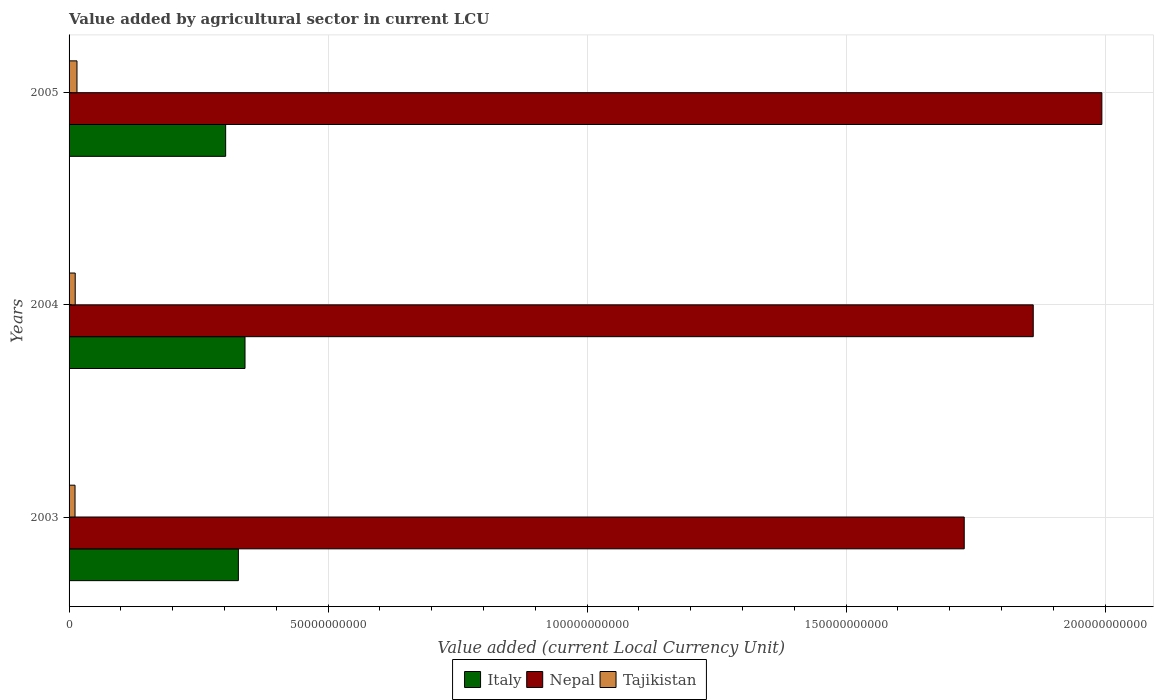How many different coloured bars are there?
Ensure brevity in your answer.  3. How many groups of bars are there?
Offer a very short reply. 3. What is the value added by agricultural sector in Nepal in 2005?
Ensure brevity in your answer.  1.99e+11. Across all years, what is the maximum value added by agricultural sector in Tajikistan?
Give a very brief answer. 1.53e+09. Across all years, what is the minimum value added by agricultural sector in Tajikistan?
Keep it short and to the point. 1.15e+09. In which year was the value added by agricultural sector in Nepal maximum?
Your answer should be compact. 2005. In which year was the value added by agricultural sector in Italy minimum?
Provide a short and direct response. 2005. What is the total value added by agricultural sector in Italy in the graph?
Keep it short and to the point. 9.69e+1. What is the difference between the value added by agricultural sector in Nepal in 2003 and that in 2005?
Provide a short and direct response. -2.66e+1. What is the difference between the value added by agricultural sector in Italy in 2004 and the value added by agricultural sector in Tajikistan in 2003?
Provide a succinct answer. 3.28e+1. What is the average value added by agricultural sector in Tajikistan per year?
Make the answer very short. 1.29e+09. In the year 2004, what is the difference between the value added by agricultural sector in Tajikistan and value added by agricultural sector in Nepal?
Ensure brevity in your answer.  -1.85e+11. What is the ratio of the value added by agricultural sector in Italy in 2003 to that in 2005?
Provide a short and direct response. 1.08. Is the value added by agricultural sector in Nepal in 2004 less than that in 2005?
Ensure brevity in your answer.  Yes. Is the difference between the value added by agricultural sector in Tajikistan in 2003 and 2005 greater than the difference between the value added by agricultural sector in Nepal in 2003 and 2005?
Offer a very short reply. Yes. What is the difference between the highest and the second highest value added by agricultural sector in Nepal?
Your answer should be very brief. 1.32e+1. What is the difference between the highest and the lowest value added by agricultural sector in Nepal?
Offer a terse response. 2.66e+1. Is the sum of the value added by agricultural sector in Nepal in 2004 and 2005 greater than the maximum value added by agricultural sector in Italy across all years?
Give a very brief answer. Yes. What does the 1st bar from the top in 2003 represents?
Ensure brevity in your answer.  Tajikistan. What does the 3rd bar from the bottom in 2005 represents?
Keep it short and to the point. Tajikistan. Is it the case that in every year, the sum of the value added by agricultural sector in Tajikistan and value added by agricultural sector in Italy is greater than the value added by agricultural sector in Nepal?
Keep it short and to the point. No. How many bars are there?
Provide a short and direct response. 9. Are all the bars in the graph horizontal?
Provide a short and direct response. Yes. How many years are there in the graph?
Give a very brief answer. 3. Are the values on the major ticks of X-axis written in scientific E-notation?
Offer a terse response. No. Does the graph contain grids?
Ensure brevity in your answer.  Yes. How many legend labels are there?
Provide a succinct answer. 3. How are the legend labels stacked?
Your answer should be very brief. Horizontal. What is the title of the graph?
Give a very brief answer. Value added by agricultural sector in current LCU. Does "Iraq" appear as one of the legend labels in the graph?
Your answer should be compact. No. What is the label or title of the X-axis?
Your answer should be compact. Value added (current Local Currency Unit). What is the Value added (current Local Currency Unit) of Italy in 2003?
Provide a succinct answer. 3.27e+1. What is the Value added (current Local Currency Unit) in Nepal in 2003?
Your answer should be compact. 1.73e+11. What is the Value added (current Local Currency Unit) in Tajikistan in 2003?
Your response must be concise. 1.15e+09. What is the Value added (current Local Currency Unit) of Italy in 2004?
Provide a succinct answer. 3.40e+1. What is the Value added (current Local Currency Unit) in Nepal in 2004?
Make the answer very short. 1.86e+11. What is the Value added (current Local Currency Unit) of Tajikistan in 2004?
Keep it short and to the point. 1.19e+09. What is the Value added (current Local Currency Unit) of Italy in 2005?
Offer a very short reply. 3.02e+1. What is the Value added (current Local Currency Unit) in Nepal in 2005?
Make the answer very short. 1.99e+11. What is the Value added (current Local Currency Unit) in Tajikistan in 2005?
Make the answer very short. 1.53e+09. Across all years, what is the maximum Value added (current Local Currency Unit) of Italy?
Provide a short and direct response. 3.40e+1. Across all years, what is the maximum Value added (current Local Currency Unit) of Nepal?
Provide a succinct answer. 1.99e+11. Across all years, what is the maximum Value added (current Local Currency Unit) of Tajikistan?
Make the answer very short. 1.53e+09. Across all years, what is the minimum Value added (current Local Currency Unit) of Italy?
Your response must be concise. 3.02e+1. Across all years, what is the minimum Value added (current Local Currency Unit) of Nepal?
Provide a succinct answer. 1.73e+11. Across all years, what is the minimum Value added (current Local Currency Unit) in Tajikistan?
Your answer should be very brief. 1.15e+09. What is the total Value added (current Local Currency Unit) in Italy in the graph?
Provide a succinct answer. 9.69e+1. What is the total Value added (current Local Currency Unit) of Nepal in the graph?
Keep it short and to the point. 5.58e+11. What is the total Value added (current Local Currency Unit) in Tajikistan in the graph?
Your answer should be very brief. 3.86e+09. What is the difference between the Value added (current Local Currency Unit) in Italy in 2003 and that in 2004?
Offer a terse response. -1.28e+09. What is the difference between the Value added (current Local Currency Unit) of Nepal in 2003 and that in 2004?
Offer a very short reply. -1.33e+1. What is the difference between the Value added (current Local Currency Unit) of Tajikistan in 2003 and that in 2004?
Ensure brevity in your answer.  -3.36e+07. What is the difference between the Value added (current Local Currency Unit) of Italy in 2003 and that in 2005?
Make the answer very short. 2.46e+09. What is the difference between the Value added (current Local Currency Unit) in Nepal in 2003 and that in 2005?
Ensure brevity in your answer.  -2.66e+1. What is the difference between the Value added (current Local Currency Unit) in Tajikistan in 2003 and that in 2005?
Offer a very short reply. -3.75e+08. What is the difference between the Value added (current Local Currency Unit) in Italy in 2004 and that in 2005?
Give a very brief answer. 3.74e+09. What is the difference between the Value added (current Local Currency Unit) of Nepal in 2004 and that in 2005?
Offer a terse response. -1.32e+1. What is the difference between the Value added (current Local Currency Unit) in Tajikistan in 2004 and that in 2005?
Offer a very short reply. -3.42e+08. What is the difference between the Value added (current Local Currency Unit) of Italy in 2003 and the Value added (current Local Currency Unit) of Nepal in 2004?
Offer a terse response. -1.53e+11. What is the difference between the Value added (current Local Currency Unit) in Italy in 2003 and the Value added (current Local Currency Unit) in Tajikistan in 2004?
Give a very brief answer. 3.15e+1. What is the difference between the Value added (current Local Currency Unit) in Nepal in 2003 and the Value added (current Local Currency Unit) in Tajikistan in 2004?
Offer a terse response. 1.72e+11. What is the difference between the Value added (current Local Currency Unit) of Italy in 2003 and the Value added (current Local Currency Unit) of Nepal in 2005?
Offer a terse response. -1.67e+11. What is the difference between the Value added (current Local Currency Unit) of Italy in 2003 and the Value added (current Local Currency Unit) of Tajikistan in 2005?
Ensure brevity in your answer.  3.12e+1. What is the difference between the Value added (current Local Currency Unit) in Nepal in 2003 and the Value added (current Local Currency Unit) in Tajikistan in 2005?
Keep it short and to the point. 1.71e+11. What is the difference between the Value added (current Local Currency Unit) of Italy in 2004 and the Value added (current Local Currency Unit) of Nepal in 2005?
Offer a very short reply. -1.65e+11. What is the difference between the Value added (current Local Currency Unit) of Italy in 2004 and the Value added (current Local Currency Unit) of Tajikistan in 2005?
Your answer should be compact. 3.24e+1. What is the difference between the Value added (current Local Currency Unit) in Nepal in 2004 and the Value added (current Local Currency Unit) in Tajikistan in 2005?
Provide a succinct answer. 1.85e+11. What is the average Value added (current Local Currency Unit) of Italy per year?
Offer a terse response. 3.23e+1. What is the average Value added (current Local Currency Unit) of Nepal per year?
Give a very brief answer. 1.86e+11. What is the average Value added (current Local Currency Unit) in Tajikistan per year?
Provide a short and direct response. 1.29e+09. In the year 2003, what is the difference between the Value added (current Local Currency Unit) of Italy and Value added (current Local Currency Unit) of Nepal?
Ensure brevity in your answer.  -1.40e+11. In the year 2003, what is the difference between the Value added (current Local Currency Unit) in Italy and Value added (current Local Currency Unit) in Tajikistan?
Your answer should be very brief. 3.15e+1. In the year 2003, what is the difference between the Value added (current Local Currency Unit) of Nepal and Value added (current Local Currency Unit) of Tajikistan?
Your response must be concise. 1.72e+11. In the year 2004, what is the difference between the Value added (current Local Currency Unit) of Italy and Value added (current Local Currency Unit) of Nepal?
Make the answer very short. -1.52e+11. In the year 2004, what is the difference between the Value added (current Local Currency Unit) in Italy and Value added (current Local Currency Unit) in Tajikistan?
Offer a very short reply. 3.28e+1. In the year 2004, what is the difference between the Value added (current Local Currency Unit) in Nepal and Value added (current Local Currency Unit) in Tajikistan?
Make the answer very short. 1.85e+11. In the year 2005, what is the difference between the Value added (current Local Currency Unit) of Italy and Value added (current Local Currency Unit) of Nepal?
Keep it short and to the point. -1.69e+11. In the year 2005, what is the difference between the Value added (current Local Currency Unit) of Italy and Value added (current Local Currency Unit) of Tajikistan?
Ensure brevity in your answer.  2.87e+1. In the year 2005, what is the difference between the Value added (current Local Currency Unit) in Nepal and Value added (current Local Currency Unit) in Tajikistan?
Offer a very short reply. 1.98e+11. What is the ratio of the Value added (current Local Currency Unit) in Italy in 2003 to that in 2004?
Offer a terse response. 0.96. What is the ratio of the Value added (current Local Currency Unit) in Nepal in 2003 to that in 2004?
Offer a terse response. 0.93. What is the ratio of the Value added (current Local Currency Unit) of Tajikistan in 2003 to that in 2004?
Keep it short and to the point. 0.97. What is the ratio of the Value added (current Local Currency Unit) in Italy in 2003 to that in 2005?
Make the answer very short. 1.08. What is the ratio of the Value added (current Local Currency Unit) in Nepal in 2003 to that in 2005?
Give a very brief answer. 0.87. What is the ratio of the Value added (current Local Currency Unit) in Tajikistan in 2003 to that in 2005?
Your response must be concise. 0.75. What is the ratio of the Value added (current Local Currency Unit) of Italy in 2004 to that in 2005?
Your answer should be very brief. 1.12. What is the ratio of the Value added (current Local Currency Unit) in Nepal in 2004 to that in 2005?
Provide a short and direct response. 0.93. What is the ratio of the Value added (current Local Currency Unit) of Tajikistan in 2004 to that in 2005?
Keep it short and to the point. 0.78. What is the difference between the highest and the second highest Value added (current Local Currency Unit) of Italy?
Your answer should be very brief. 1.28e+09. What is the difference between the highest and the second highest Value added (current Local Currency Unit) of Nepal?
Your answer should be very brief. 1.32e+1. What is the difference between the highest and the second highest Value added (current Local Currency Unit) in Tajikistan?
Ensure brevity in your answer.  3.42e+08. What is the difference between the highest and the lowest Value added (current Local Currency Unit) of Italy?
Make the answer very short. 3.74e+09. What is the difference between the highest and the lowest Value added (current Local Currency Unit) of Nepal?
Ensure brevity in your answer.  2.66e+1. What is the difference between the highest and the lowest Value added (current Local Currency Unit) in Tajikistan?
Your answer should be compact. 3.75e+08. 